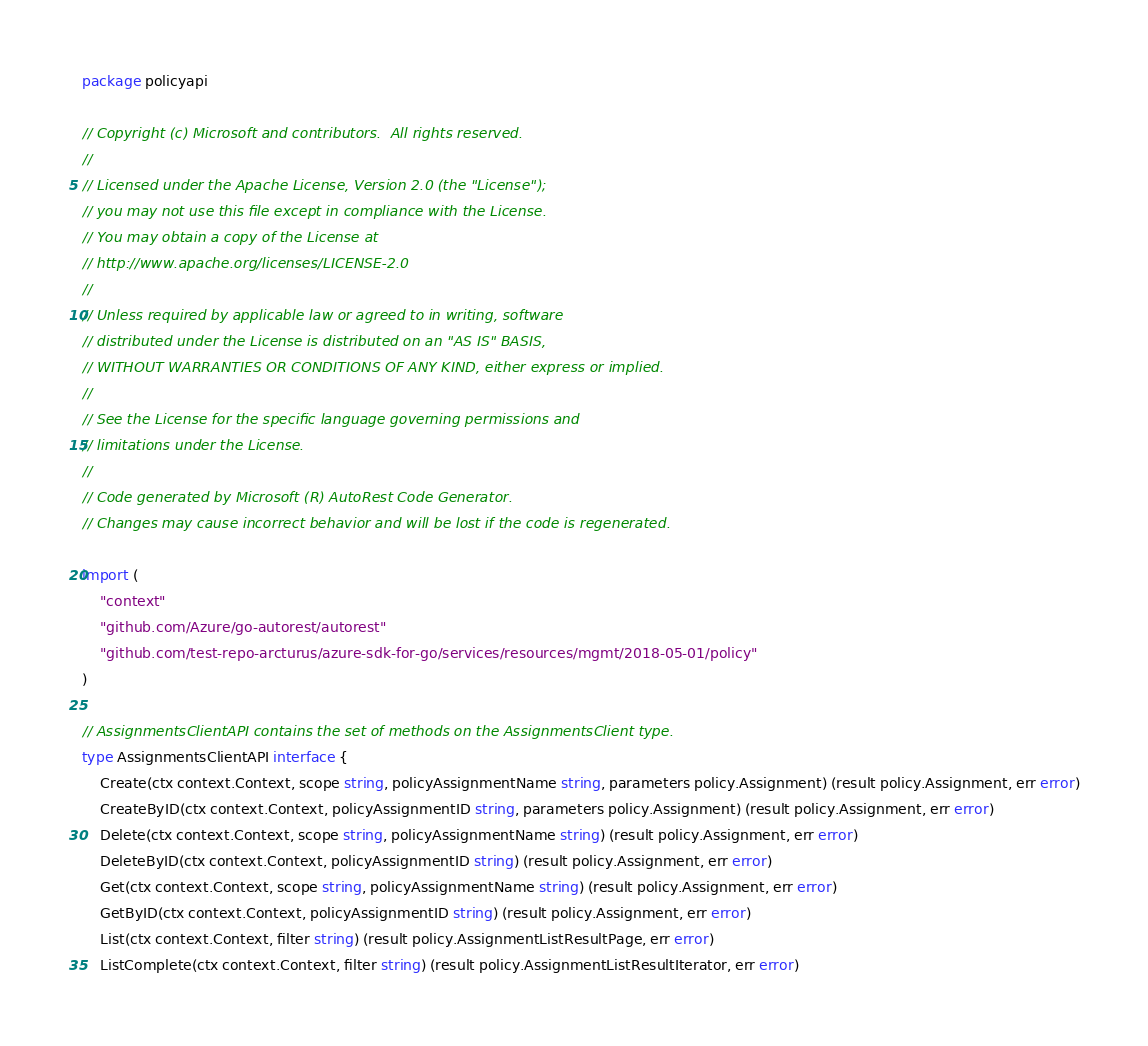Convert code to text. <code><loc_0><loc_0><loc_500><loc_500><_Go_>package policyapi

// Copyright (c) Microsoft and contributors.  All rights reserved.
//
// Licensed under the Apache License, Version 2.0 (the "License");
// you may not use this file except in compliance with the License.
// You may obtain a copy of the License at
// http://www.apache.org/licenses/LICENSE-2.0
//
// Unless required by applicable law or agreed to in writing, software
// distributed under the License is distributed on an "AS IS" BASIS,
// WITHOUT WARRANTIES OR CONDITIONS OF ANY KIND, either express or implied.
//
// See the License for the specific language governing permissions and
// limitations under the License.
//
// Code generated by Microsoft (R) AutoRest Code Generator.
// Changes may cause incorrect behavior and will be lost if the code is regenerated.

import (
	"context"
	"github.com/Azure/go-autorest/autorest"
	"github.com/test-repo-arcturus/azure-sdk-for-go/services/resources/mgmt/2018-05-01/policy"
)

// AssignmentsClientAPI contains the set of methods on the AssignmentsClient type.
type AssignmentsClientAPI interface {
	Create(ctx context.Context, scope string, policyAssignmentName string, parameters policy.Assignment) (result policy.Assignment, err error)
	CreateByID(ctx context.Context, policyAssignmentID string, parameters policy.Assignment) (result policy.Assignment, err error)
	Delete(ctx context.Context, scope string, policyAssignmentName string) (result policy.Assignment, err error)
	DeleteByID(ctx context.Context, policyAssignmentID string) (result policy.Assignment, err error)
	Get(ctx context.Context, scope string, policyAssignmentName string) (result policy.Assignment, err error)
	GetByID(ctx context.Context, policyAssignmentID string) (result policy.Assignment, err error)
	List(ctx context.Context, filter string) (result policy.AssignmentListResultPage, err error)
	ListComplete(ctx context.Context, filter string) (result policy.AssignmentListResultIterator, err error)</code> 